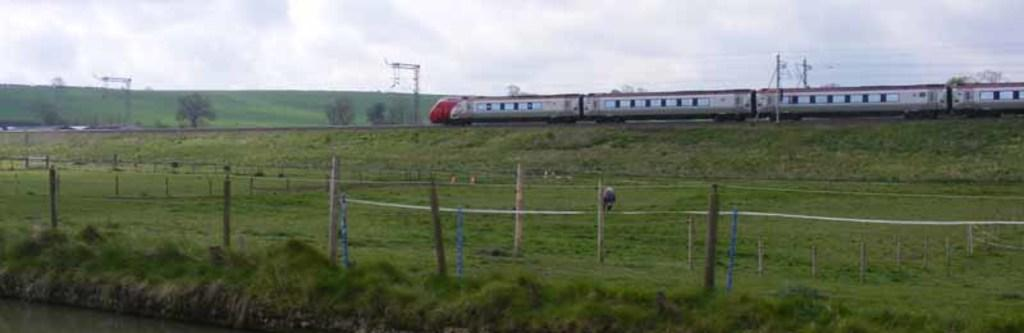What type of vegetation can be seen in the image? There is grass in the image. What structures are present in the image? There are poles in the image. What mode of transportation is visible in the image? There is a train in the image. What other natural elements can be seen in the image? There are trees in the image. Can you describe any other objects in the image? There are some objects in the image. What is visible in the background of the image? The sky is visible in the background of the image. What type of copper material can be seen in the image? There is no copper material present in the image. How many clouds are visible in the image? There is no mention of clouds in the image; only the sky is visible in the background. 